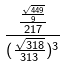Convert formula to latex. <formula><loc_0><loc_0><loc_500><loc_500>\frac { \frac { \frac { \sqrt { 4 4 9 } } { 9 } } { 2 1 7 } } { ( \frac { \sqrt { 3 1 8 } } { 3 1 3 } ) ^ { 3 } }</formula> 